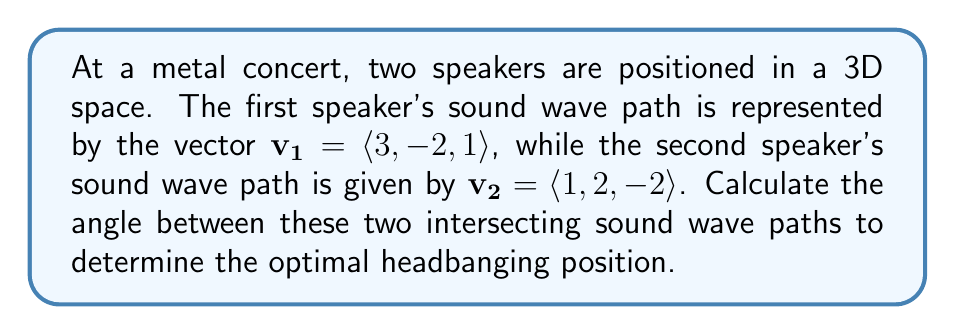Solve this math problem. To find the angle between two vectors in 3D space, we can use the dot product formula:

$$\cos \theta = \frac{\mathbf{v_1} \cdot \mathbf{v_2}}{|\mathbf{v_1}| |\mathbf{v_2}|}$$

Step 1: Calculate the dot product $\mathbf{v_1} \cdot \mathbf{v_2}$
$$\mathbf{v_1} \cdot \mathbf{v_2} = (3)(1) + (-2)(2) + (1)(-2) = 3 - 4 - 2 = -3$$

Step 2: Calculate the magnitudes of $\mathbf{v_1}$ and $\mathbf{v_2}$
$$|\mathbf{v_1}| = \sqrt{3^2 + (-2)^2 + 1^2} = \sqrt{9 + 4 + 1} = \sqrt{14}$$
$$|\mathbf{v_2}| = \sqrt{1^2 + 2^2 + (-2)^2} = \sqrt{1 + 4 + 4} = 3$$

Step 3: Substitute into the formula
$$\cos \theta = \frac{-3}{\sqrt{14} \cdot 3} = \frac{-3}{3\sqrt{14}} = -\frac{1}{\sqrt{14}}$$

Step 4: Take the inverse cosine (arccos) of both sides
$$\theta = \arccos(-\frac{1}{\sqrt{14}})$$

Step 5: Calculate the result (rounded to two decimal places)
$$\theta \approx 1.82 \text{ radians} \approx 104.48°$$
Answer: $104.48°$ 